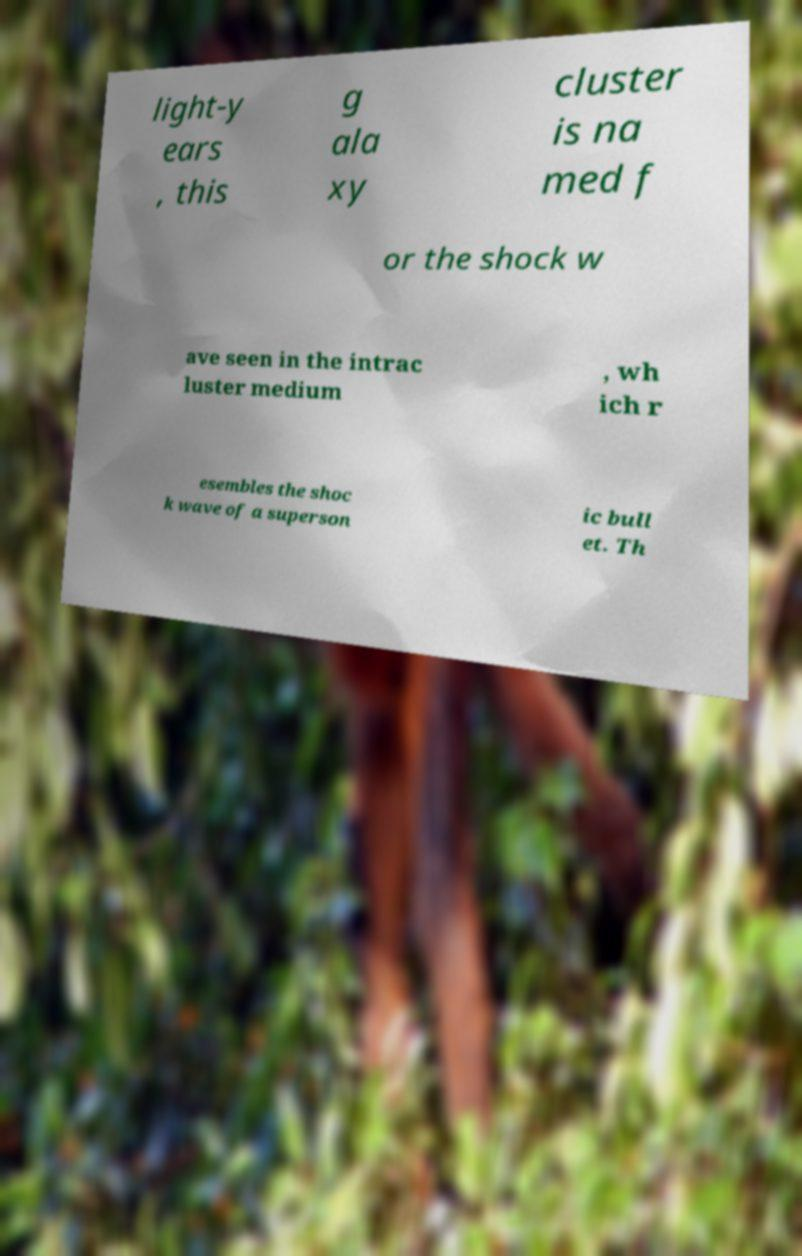Please read and relay the text visible in this image. What does it say? light-y ears , this g ala xy cluster is na med f or the shock w ave seen in the intrac luster medium , wh ich r esembles the shoc k wave of a superson ic bull et. Th 